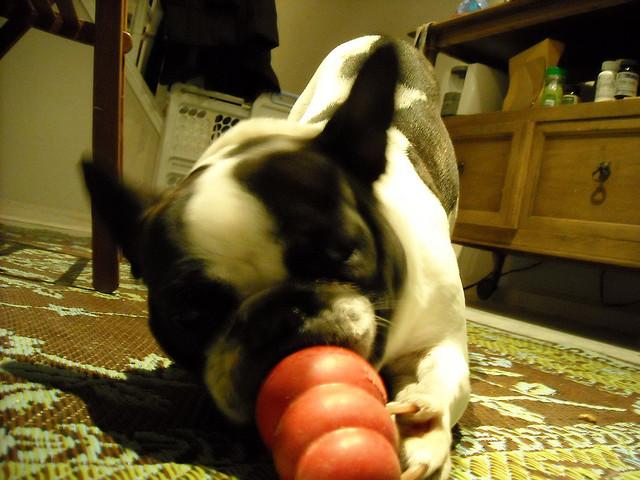Is the dog laying outside?
Quick response, please. No. Is the playing?
Be succinct. Yes. Where is the dog sitting?
Give a very brief answer. Floor. Are there stuff animal in the background?
Quick response, please. No. What color is the dog?
Short answer required. White and black. 